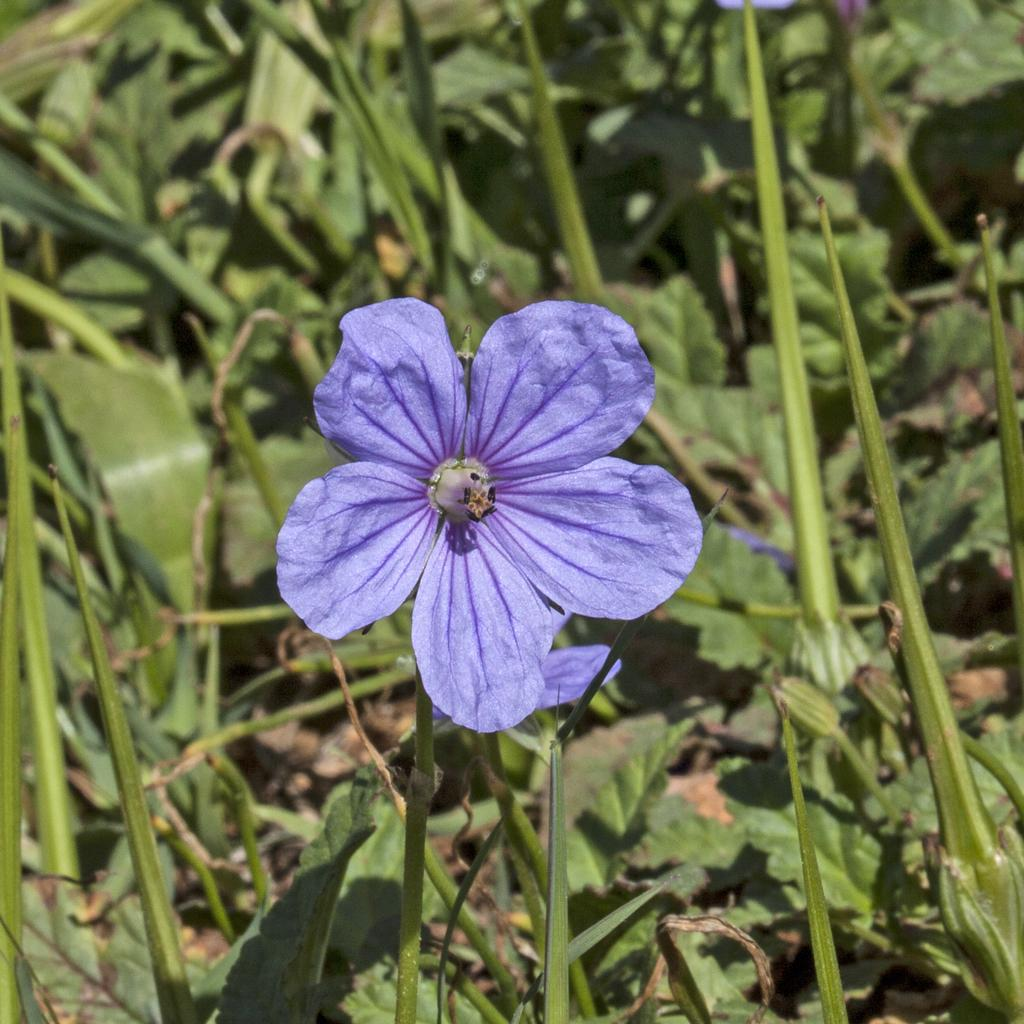What type of plant life can be seen in the image? There are flowers, plant stems, and leaves visible in the image. Can you describe the individual components of the plants in the image? Yes, the image shows flowers, plant stems, and leaves. What part of the plants are responsible for absorbing sunlight and producing food? The leaves are responsible for absorbing sunlight and producing food through the process of photosynthesis. How many heads of cattle can be seen grazing in the image? There are no heads of cattle or any farm-related elements present in the image; it features flowers, plant stems, and leaves. 